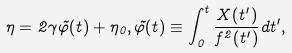<formula> <loc_0><loc_0><loc_500><loc_500>\eta = 2 \gamma \tilde { \varphi } ( t ) + \eta _ { 0 } , \tilde { \varphi } ( t ) \equiv \int _ { 0 } ^ { t } \frac { X ( t ^ { \prime } ) } { f ^ { 2 } ( t ^ { \prime } ) } d t ^ { \prime } ,</formula> 